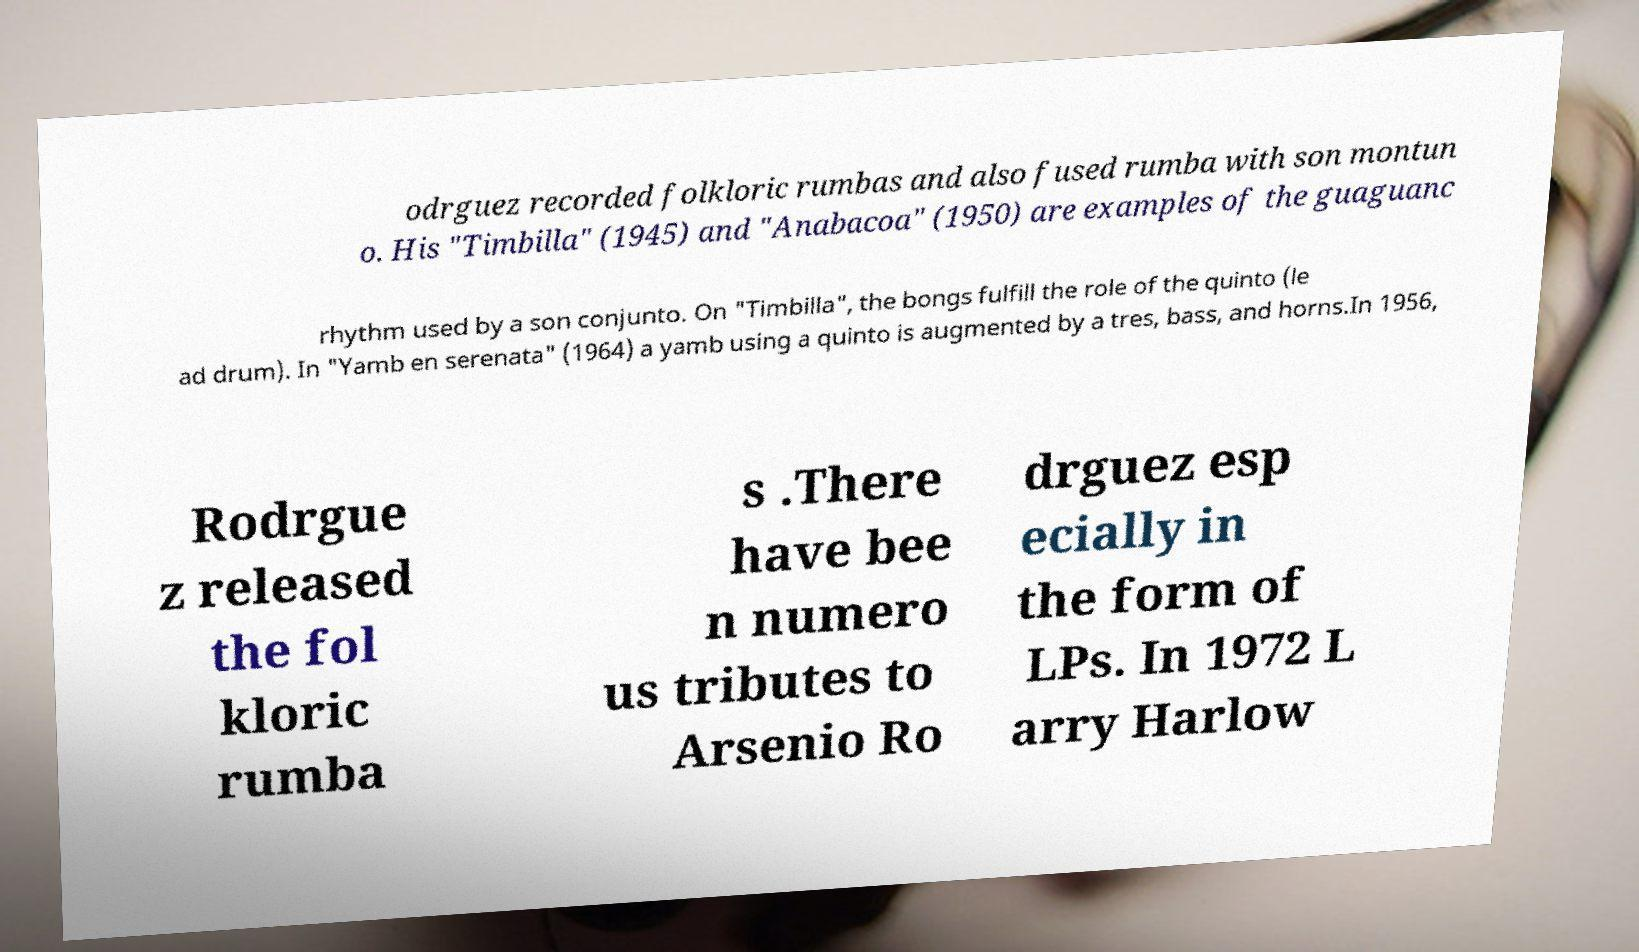What messages or text are displayed in this image? I need them in a readable, typed format. odrguez recorded folkloric rumbas and also fused rumba with son montun o. His "Timbilla" (1945) and "Anabacoa" (1950) are examples of the guaguanc rhythm used by a son conjunto. On "Timbilla", the bongs fulfill the role of the quinto (le ad drum). In "Yamb en serenata" (1964) a yamb using a quinto is augmented by a tres, bass, and horns.In 1956, Rodrgue z released the fol kloric rumba s .There have bee n numero us tributes to Arsenio Ro drguez esp ecially in the form of LPs. In 1972 L arry Harlow 